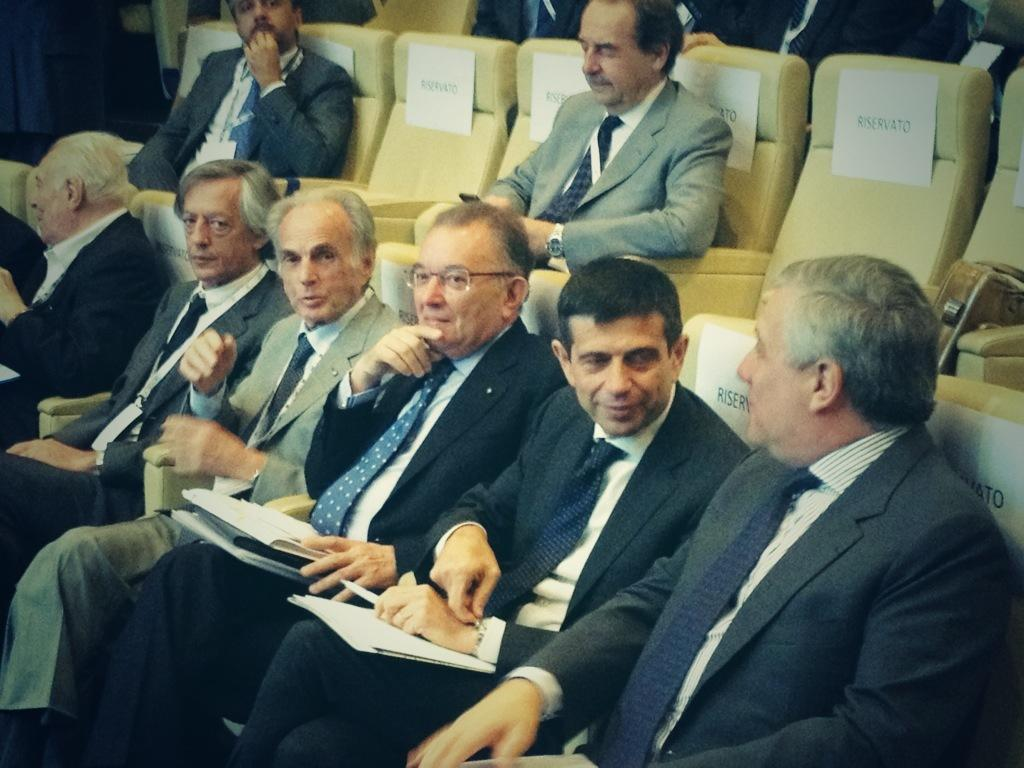What are the people in the image doing? The people in the image are sitting on chairs. What can be seen on the chairs besides the people? Papers with text are present on the chairs. What are the people holding in their hands? There are people holding something in their hands in the image. What type of silk fabric is draped over the chairs in the image? There is no silk fabric present in the image; the chairs have papers with text on them. 